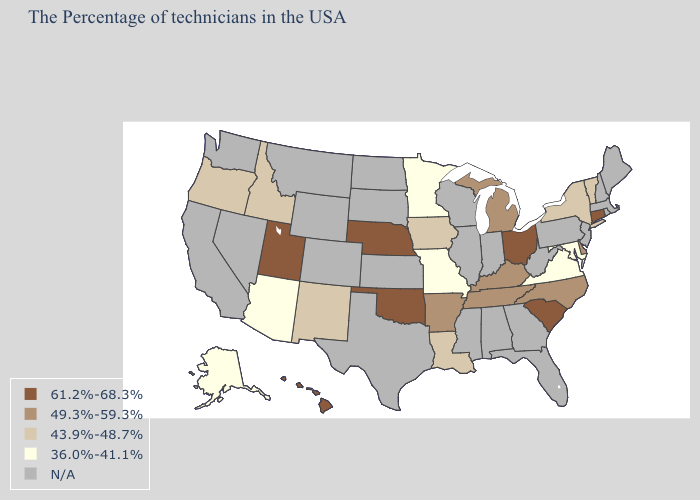Does Iowa have the highest value in the USA?
Keep it brief. No. What is the value of Kentucky?
Short answer required. 49.3%-59.3%. What is the value of Utah?
Be succinct. 61.2%-68.3%. Among the states that border Tennessee , does Virginia have the lowest value?
Answer briefly. Yes. What is the value of Ohio?
Be succinct. 61.2%-68.3%. Which states hav the highest value in the West?
Keep it brief. Utah, Hawaii. Name the states that have a value in the range 49.3%-59.3%?
Quick response, please. Delaware, North Carolina, Michigan, Kentucky, Tennessee, Arkansas. What is the value of Nevada?
Be succinct. N/A. Among the states that border Colorado , which have the lowest value?
Quick response, please. Arizona. What is the lowest value in states that border South Dakota?
Answer briefly. 36.0%-41.1%. What is the highest value in the USA?
Keep it brief. 61.2%-68.3%. Name the states that have a value in the range 61.2%-68.3%?
Concise answer only. Connecticut, South Carolina, Ohio, Nebraska, Oklahoma, Utah, Hawaii. Does Virginia have the lowest value in the South?
Quick response, please. Yes. 